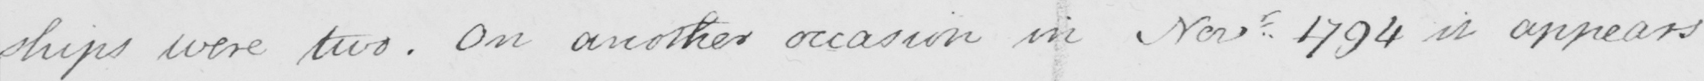Transcribe the text shown in this historical manuscript line. ships were two . On another occasion in Nov . 1794 it appears 